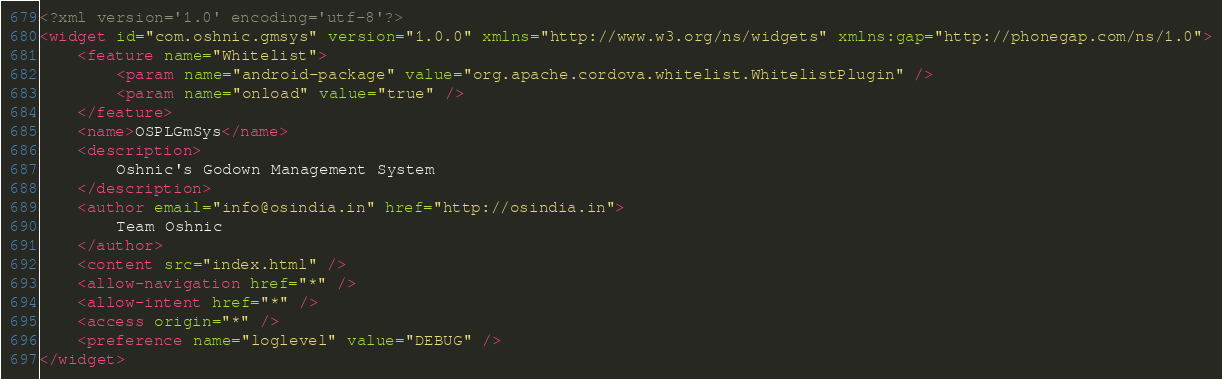<code> <loc_0><loc_0><loc_500><loc_500><_XML_><?xml version='1.0' encoding='utf-8'?>
<widget id="com.oshnic.gmsys" version="1.0.0" xmlns="http://www.w3.org/ns/widgets" xmlns:gap="http://phonegap.com/ns/1.0">
    <feature name="Whitelist">
        <param name="android-package" value="org.apache.cordova.whitelist.WhitelistPlugin" />
        <param name="onload" value="true" />
    </feature>
    <name>OSPLGmSys</name>
    <description>
        Oshnic's Godown Management System
    </description>
    <author email="info@osindia.in" href="http://osindia.in">
        Team Oshnic 
    </author>
    <content src="index.html" />
    <allow-navigation href="*" />
    <allow-intent href="*" />
    <access origin="*" />
    <preference name="loglevel" value="DEBUG" />
</widget>
</code> 